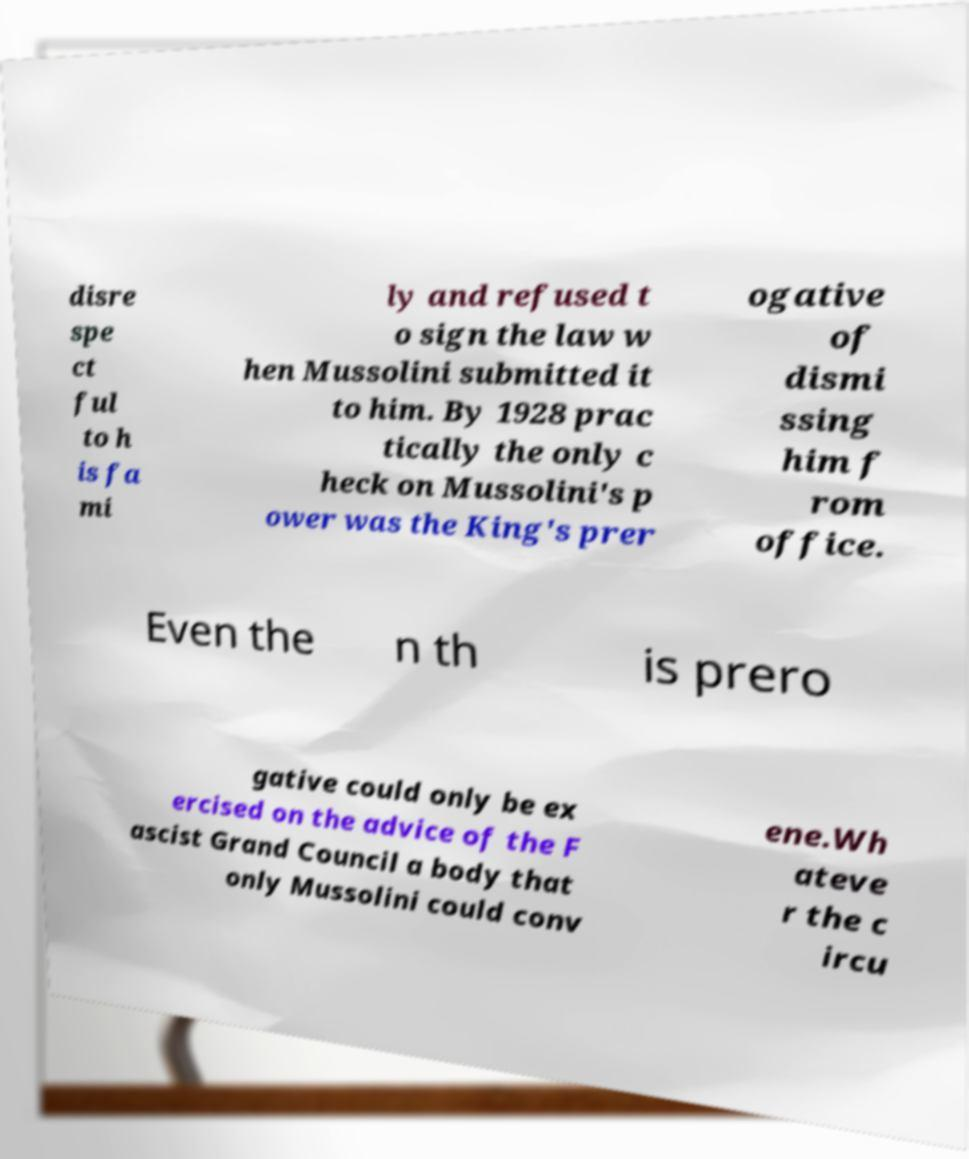For documentation purposes, I need the text within this image transcribed. Could you provide that? disre spe ct ful to h is fa mi ly and refused t o sign the law w hen Mussolini submitted it to him. By 1928 prac tically the only c heck on Mussolini's p ower was the King's prer ogative of dismi ssing him f rom office. Even the n th is prero gative could only be ex ercised on the advice of the F ascist Grand Council a body that only Mussolini could conv ene.Wh ateve r the c ircu 